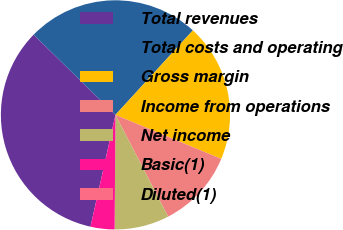Convert chart. <chart><loc_0><loc_0><loc_500><loc_500><pie_chart><fcel>Total revenues<fcel>Total costs and operating<fcel>Gross margin<fcel>Income from operations<fcel>Net income<fcel>Basic(1)<fcel>Diluted(1)<nl><fcel>33.85%<fcel>24.46%<fcel>19.48%<fcel>11.11%<fcel>7.72%<fcel>3.38%<fcel>0.0%<nl></chart> 